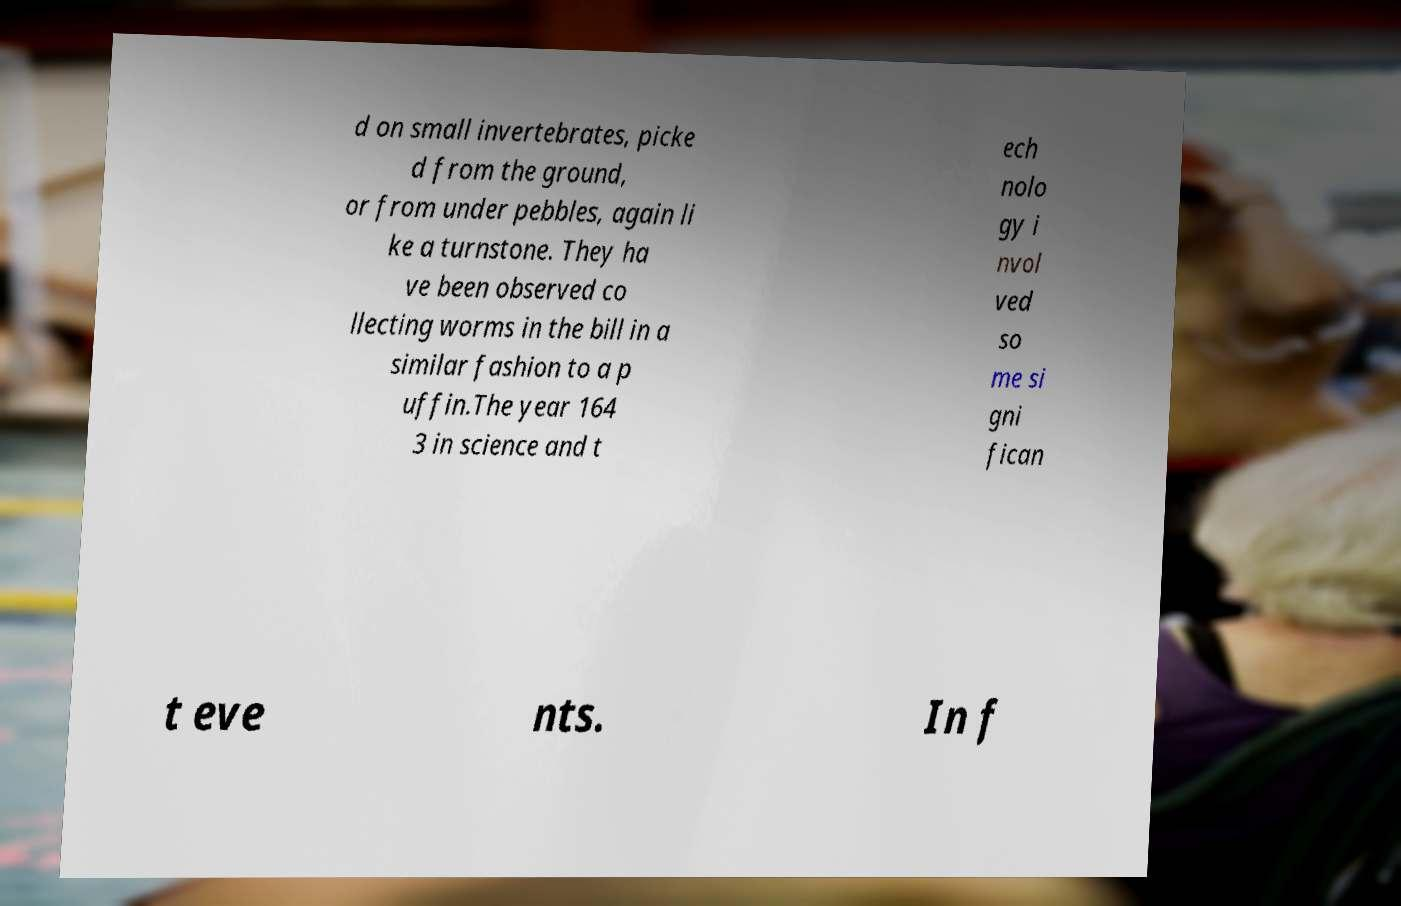For documentation purposes, I need the text within this image transcribed. Could you provide that? d on small invertebrates, picke d from the ground, or from under pebbles, again li ke a turnstone. They ha ve been observed co llecting worms in the bill in a similar fashion to a p uffin.The year 164 3 in science and t ech nolo gy i nvol ved so me si gni fican t eve nts. In f 